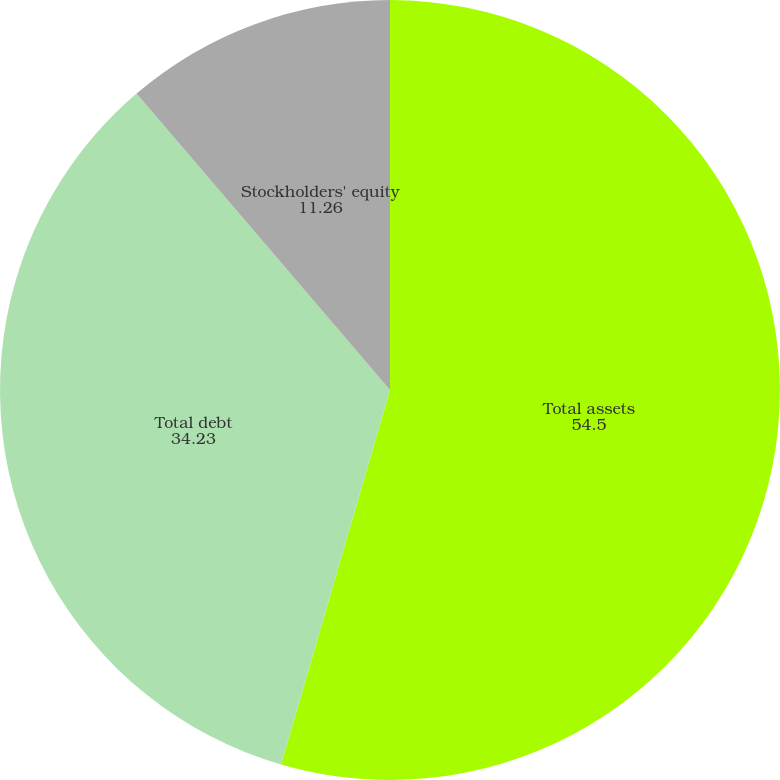Convert chart. <chart><loc_0><loc_0><loc_500><loc_500><pie_chart><fcel>Total assets<fcel>Total debt<fcel>Stockholders' equity<nl><fcel>54.5%<fcel>34.23%<fcel>11.26%<nl></chart> 